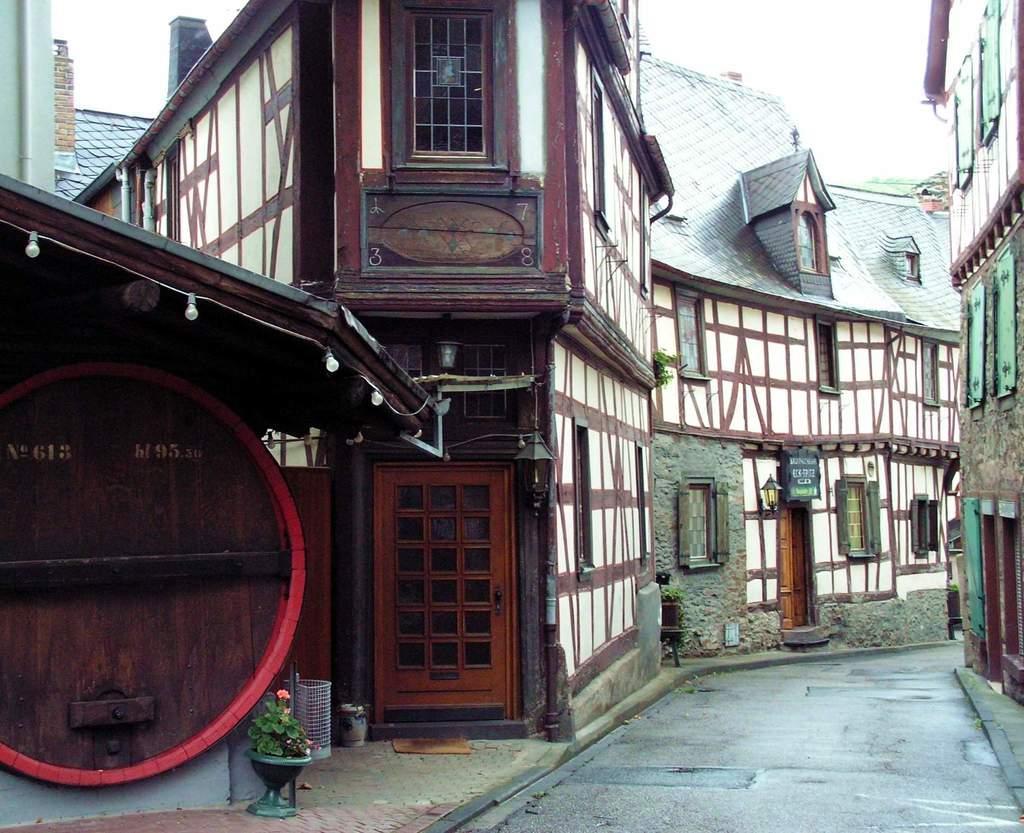Describe this image in one or two sentences. This image consists of buildings in the middle. There are lights in the middle. There is sky at the top. There is a plant at the bottom. 